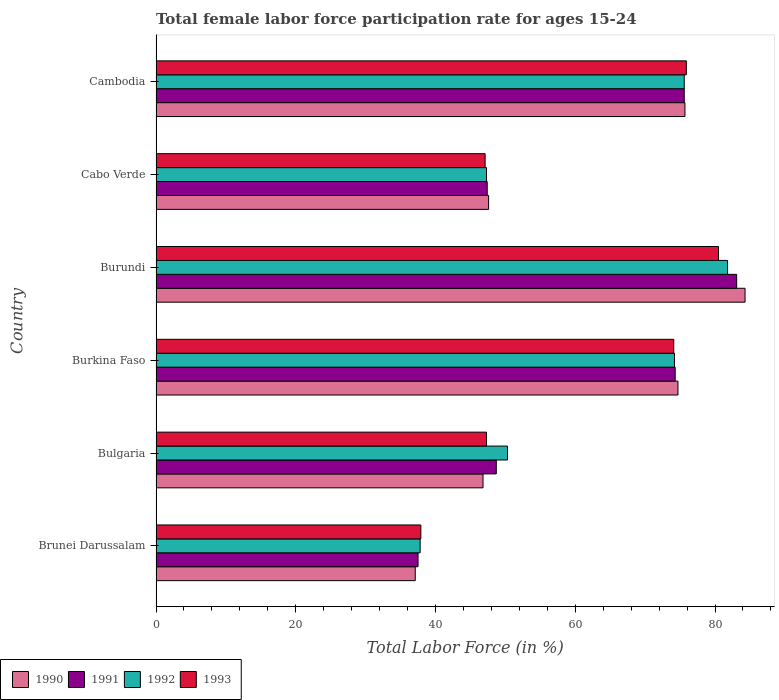How many groups of bars are there?
Ensure brevity in your answer.  6. Are the number of bars per tick equal to the number of legend labels?
Offer a terse response. Yes. How many bars are there on the 4th tick from the top?
Offer a very short reply. 4. What is the label of the 1st group of bars from the top?
Provide a succinct answer. Cambodia. In how many cases, is the number of bars for a given country not equal to the number of legend labels?
Your answer should be compact. 0. What is the female labor force participation rate in 1990 in Cambodia?
Offer a terse response. 75.7. Across all countries, what is the maximum female labor force participation rate in 1992?
Your response must be concise. 81.8. Across all countries, what is the minimum female labor force participation rate in 1992?
Offer a terse response. 37.8. In which country was the female labor force participation rate in 1993 maximum?
Your answer should be very brief. Burundi. In which country was the female labor force participation rate in 1993 minimum?
Make the answer very short. Brunei Darussalam. What is the total female labor force participation rate in 1990 in the graph?
Offer a very short reply. 366.2. What is the difference between the female labor force participation rate in 1991 in Bulgaria and that in Cabo Verde?
Offer a very short reply. 1.3. What is the difference between the female labor force participation rate in 1993 in Brunei Darussalam and the female labor force participation rate in 1991 in Bulgaria?
Make the answer very short. -10.8. What is the average female labor force participation rate in 1993 per country?
Give a very brief answer. 60.47. What is the difference between the female labor force participation rate in 1993 and female labor force participation rate in 1992 in Cambodia?
Offer a terse response. 0.3. What is the ratio of the female labor force participation rate in 1992 in Brunei Darussalam to that in Cabo Verde?
Provide a short and direct response. 0.8. Is the female labor force participation rate in 1990 in Burundi less than that in Cambodia?
Your answer should be compact. No. Is the difference between the female labor force participation rate in 1993 in Bulgaria and Cabo Verde greater than the difference between the female labor force participation rate in 1992 in Bulgaria and Cabo Verde?
Give a very brief answer. No. What is the difference between the highest and the second highest female labor force participation rate in 1993?
Provide a short and direct response. 4.6. What is the difference between the highest and the lowest female labor force participation rate in 1991?
Keep it short and to the point. 45.6. In how many countries, is the female labor force participation rate in 1992 greater than the average female labor force participation rate in 1992 taken over all countries?
Offer a very short reply. 3. Is the sum of the female labor force participation rate in 1992 in Bulgaria and Burkina Faso greater than the maximum female labor force participation rate in 1990 across all countries?
Your response must be concise. Yes. Is it the case that in every country, the sum of the female labor force participation rate in 1993 and female labor force participation rate in 1990 is greater than the sum of female labor force participation rate in 1991 and female labor force participation rate in 1992?
Provide a short and direct response. No. What does the 1st bar from the top in Cambodia represents?
Ensure brevity in your answer.  1993. How many bars are there?
Keep it short and to the point. 24. What is the difference between two consecutive major ticks on the X-axis?
Make the answer very short. 20. Are the values on the major ticks of X-axis written in scientific E-notation?
Give a very brief answer. No. Does the graph contain any zero values?
Your answer should be compact. No. How are the legend labels stacked?
Offer a terse response. Horizontal. What is the title of the graph?
Your response must be concise. Total female labor force participation rate for ages 15-24. Does "1992" appear as one of the legend labels in the graph?
Ensure brevity in your answer.  Yes. What is the label or title of the X-axis?
Provide a short and direct response. Total Labor Force (in %). What is the label or title of the Y-axis?
Provide a short and direct response. Country. What is the Total Labor Force (in %) of 1990 in Brunei Darussalam?
Offer a very short reply. 37.1. What is the Total Labor Force (in %) in 1991 in Brunei Darussalam?
Provide a short and direct response. 37.5. What is the Total Labor Force (in %) in 1992 in Brunei Darussalam?
Your response must be concise. 37.8. What is the Total Labor Force (in %) in 1993 in Brunei Darussalam?
Ensure brevity in your answer.  37.9. What is the Total Labor Force (in %) in 1990 in Bulgaria?
Provide a short and direct response. 46.8. What is the Total Labor Force (in %) in 1991 in Bulgaria?
Provide a succinct answer. 48.7. What is the Total Labor Force (in %) in 1992 in Bulgaria?
Provide a succinct answer. 50.3. What is the Total Labor Force (in %) of 1993 in Bulgaria?
Give a very brief answer. 47.3. What is the Total Labor Force (in %) in 1990 in Burkina Faso?
Offer a terse response. 74.7. What is the Total Labor Force (in %) in 1991 in Burkina Faso?
Keep it short and to the point. 74.3. What is the Total Labor Force (in %) of 1992 in Burkina Faso?
Offer a very short reply. 74.2. What is the Total Labor Force (in %) of 1993 in Burkina Faso?
Give a very brief answer. 74.1. What is the Total Labor Force (in %) in 1990 in Burundi?
Your answer should be compact. 84.3. What is the Total Labor Force (in %) in 1991 in Burundi?
Make the answer very short. 83.1. What is the Total Labor Force (in %) of 1992 in Burundi?
Offer a terse response. 81.8. What is the Total Labor Force (in %) of 1993 in Burundi?
Keep it short and to the point. 80.5. What is the Total Labor Force (in %) in 1990 in Cabo Verde?
Ensure brevity in your answer.  47.6. What is the Total Labor Force (in %) in 1991 in Cabo Verde?
Offer a very short reply. 47.4. What is the Total Labor Force (in %) in 1992 in Cabo Verde?
Offer a terse response. 47.3. What is the Total Labor Force (in %) of 1993 in Cabo Verde?
Make the answer very short. 47.1. What is the Total Labor Force (in %) in 1990 in Cambodia?
Your answer should be very brief. 75.7. What is the Total Labor Force (in %) in 1991 in Cambodia?
Make the answer very short. 75.6. What is the Total Labor Force (in %) of 1992 in Cambodia?
Give a very brief answer. 75.6. What is the Total Labor Force (in %) of 1993 in Cambodia?
Make the answer very short. 75.9. Across all countries, what is the maximum Total Labor Force (in %) in 1990?
Provide a succinct answer. 84.3. Across all countries, what is the maximum Total Labor Force (in %) of 1991?
Give a very brief answer. 83.1. Across all countries, what is the maximum Total Labor Force (in %) in 1992?
Keep it short and to the point. 81.8. Across all countries, what is the maximum Total Labor Force (in %) of 1993?
Your answer should be compact. 80.5. Across all countries, what is the minimum Total Labor Force (in %) of 1990?
Your answer should be very brief. 37.1. Across all countries, what is the minimum Total Labor Force (in %) in 1991?
Offer a very short reply. 37.5. Across all countries, what is the minimum Total Labor Force (in %) of 1992?
Your answer should be compact. 37.8. Across all countries, what is the minimum Total Labor Force (in %) of 1993?
Provide a succinct answer. 37.9. What is the total Total Labor Force (in %) in 1990 in the graph?
Ensure brevity in your answer.  366.2. What is the total Total Labor Force (in %) in 1991 in the graph?
Make the answer very short. 366.6. What is the total Total Labor Force (in %) in 1992 in the graph?
Ensure brevity in your answer.  367. What is the total Total Labor Force (in %) of 1993 in the graph?
Offer a terse response. 362.8. What is the difference between the Total Labor Force (in %) in 1990 in Brunei Darussalam and that in Bulgaria?
Your response must be concise. -9.7. What is the difference between the Total Labor Force (in %) of 1990 in Brunei Darussalam and that in Burkina Faso?
Provide a succinct answer. -37.6. What is the difference between the Total Labor Force (in %) of 1991 in Brunei Darussalam and that in Burkina Faso?
Keep it short and to the point. -36.8. What is the difference between the Total Labor Force (in %) of 1992 in Brunei Darussalam and that in Burkina Faso?
Keep it short and to the point. -36.4. What is the difference between the Total Labor Force (in %) in 1993 in Brunei Darussalam and that in Burkina Faso?
Offer a terse response. -36.2. What is the difference between the Total Labor Force (in %) of 1990 in Brunei Darussalam and that in Burundi?
Your response must be concise. -47.2. What is the difference between the Total Labor Force (in %) of 1991 in Brunei Darussalam and that in Burundi?
Your response must be concise. -45.6. What is the difference between the Total Labor Force (in %) in 1992 in Brunei Darussalam and that in Burundi?
Your answer should be compact. -44. What is the difference between the Total Labor Force (in %) in 1993 in Brunei Darussalam and that in Burundi?
Provide a short and direct response. -42.6. What is the difference between the Total Labor Force (in %) of 1991 in Brunei Darussalam and that in Cabo Verde?
Offer a terse response. -9.9. What is the difference between the Total Labor Force (in %) in 1992 in Brunei Darussalam and that in Cabo Verde?
Ensure brevity in your answer.  -9.5. What is the difference between the Total Labor Force (in %) in 1993 in Brunei Darussalam and that in Cabo Verde?
Give a very brief answer. -9.2. What is the difference between the Total Labor Force (in %) in 1990 in Brunei Darussalam and that in Cambodia?
Offer a very short reply. -38.6. What is the difference between the Total Labor Force (in %) of 1991 in Brunei Darussalam and that in Cambodia?
Offer a very short reply. -38.1. What is the difference between the Total Labor Force (in %) of 1992 in Brunei Darussalam and that in Cambodia?
Your answer should be very brief. -37.8. What is the difference between the Total Labor Force (in %) in 1993 in Brunei Darussalam and that in Cambodia?
Ensure brevity in your answer.  -38. What is the difference between the Total Labor Force (in %) of 1990 in Bulgaria and that in Burkina Faso?
Provide a succinct answer. -27.9. What is the difference between the Total Labor Force (in %) of 1991 in Bulgaria and that in Burkina Faso?
Keep it short and to the point. -25.6. What is the difference between the Total Labor Force (in %) of 1992 in Bulgaria and that in Burkina Faso?
Give a very brief answer. -23.9. What is the difference between the Total Labor Force (in %) of 1993 in Bulgaria and that in Burkina Faso?
Keep it short and to the point. -26.8. What is the difference between the Total Labor Force (in %) in 1990 in Bulgaria and that in Burundi?
Your answer should be compact. -37.5. What is the difference between the Total Labor Force (in %) in 1991 in Bulgaria and that in Burundi?
Provide a succinct answer. -34.4. What is the difference between the Total Labor Force (in %) of 1992 in Bulgaria and that in Burundi?
Offer a very short reply. -31.5. What is the difference between the Total Labor Force (in %) of 1993 in Bulgaria and that in Burundi?
Give a very brief answer. -33.2. What is the difference between the Total Labor Force (in %) of 1991 in Bulgaria and that in Cabo Verde?
Your response must be concise. 1.3. What is the difference between the Total Labor Force (in %) in 1993 in Bulgaria and that in Cabo Verde?
Offer a terse response. 0.2. What is the difference between the Total Labor Force (in %) of 1990 in Bulgaria and that in Cambodia?
Provide a short and direct response. -28.9. What is the difference between the Total Labor Force (in %) in 1991 in Bulgaria and that in Cambodia?
Offer a very short reply. -26.9. What is the difference between the Total Labor Force (in %) in 1992 in Bulgaria and that in Cambodia?
Offer a terse response. -25.3. What is the difference between the Total Labor Force (in %) in 1993 in Bulgaria and that in Cambodia?
Keep it short and to the point. -28.6. What is the difference between the Total Labor Force (in %) of 1990 in Burkina Faso and that in Burundi?
Make the answer very short. -9.6. What is the difference between the Total Labor Force (in %) of 1991 in Burkina Faso and that in Burundi?
Your response must be concise. -8.8. What is the difference between the Total Labor Force (in %) of 1990 in Burkina Faso and that in Cabo Verde?
Your response must be concise. 27.1. What is the difference between the Total Labor Force (in %) in 1991 in Burkina Faso and that in Cabo Verde?
Ensure brevity in your answer.  26.9. What is the difference between the Total Labor Force (in %) in 1992 in Burkina Faso and that in Cabo Verde?
Ensure brevity in your answer.  26.9. What is the difference between the Total Labor Force (in %) in 1990 in Burkina Faso and that in Cambodia?
Offer a very short reply. -1. What is the difference between the Total Labor Force (in %) of 1991 in Burkina Faso and that in Cambodia?
Your answer should be compact. -1.3. What is the difference between the Total Labor Force (in %) in 1992 in Burkina Faso and that in Cambodia?
Offer a terse response. -1.4. What is the difference between the Total Labor Force (in %) in 1990 in Burundi and that in Cabo Verde?
Your answer should be very brief. 36.7. What is the difference between the Total Labor Force (in %) of 1991 in Burundi and that in Cabo Verde?
Provide a short and direct response. 35.7. What is the difference between the Total Labor Force (in %) of 1992 in Burundi and that in Cabo Verde?
Your answer should be compact. 34.5. What is the difference between the Total Labor Force (in %) in 1993 in Burundi and that in Cabo Verde?
Your answer should be very brief. 33.4. What is the difference between the Total Labor Force (in %) in 1990 in Burundi and that in Cambodia?
Provide a succinct answer. 8.6. What is the difference between the Total Labor Force (in %) in 1990 in Cabo Verde and that in Cambodia?
Your answer should be very brief. -28.1. What is the difference between the Total Labor Force (in %) in 1991 in Cabo Verde and that in Cambodia?
Make the answer very short. -28.2. What is the difference between the Total Labor Force (in %) in 1992 in Cabo Verde and that in Cambodia?
Keep it short and to the point. -28.3. What is the difference between the Total Labor Force (in %) of 1993 in Cabo Verde and that in Cambodia?
Your response must be concise. -28.8. What is the difference between the Total Labor Force (in %) in 1990 in Brunei Darussalam and the Total Labor Force (in %) in 1992 in Bulgaria?
Ensure brevity in your answer.  -13.2. What is the difference between the Total Labor Force (in %) in 1991 in Brunei Darussalam and the Total Labor Force (in %) in 1992 in Bulgaria?
Give a very brief answer. -12.8. What is the difference between the Total Labor Force (in %) in 1991 in Brunei Darussalam and the Total Labor Force (in %) in 1993 in Bulgaria?
Your answer should be very brief. -9.8. What is the difference between the Total Labor Force (in %) of 1990 in Brunei Darussalam and the Total Labor Force (in %) of 1991 in Burkina Faso?
Provide a succinct answer. -37.2. What is the difference between the Total Labor Force (in %) of 1990 in Brunei Darussalam and the Total Labor Force (in %) of 1992 in Burkina Faso?
Your response must be concise. -37.1. What is the difference between the Total Labor Force (in %) of 1990 in Brunei Darussalam and the Total Labor Force (in %) of 1993 in Burkina Faso?
Your answer should be compact. -37. What is the difference between the Total Labor Force (in %) in 1991 in Brunei Darussalam and the Total Labor Force (in %) in 1992 in Burkina Faso?
Offer a very short reply. -36.7. What is the difference between the Total Labor Force (in %) of 1991 in Brunei Darussalam and the Total Labor Force (in %) of 1993 in Burkina Faso?
Keep it short and to the point. -36.6. What is the difference between the Total Labor Force (in %) in 1992 in Brunei Darussalam and the Total Labor Force (in %) in 1993 in Burkina Faso?
Your response must be concise. -36.3. What is the difference between the Total Labor Force (in %) in 1990 in Brunei Darussalam and the Total Labor Force (in %) in 1991 in Burundi?
Offer a terse response. -46. What is the difference between the Total Labor Force (in %) in 1990 in Brunei Darussalam and the Total Labor Force (in %) in 1992 in Burundi?
Keep it short and to the point. -44.7. What is the difference between the Total Labor Force (in %) in 1990 in Brunei Darussalam and the Total Labor Force (in %) in 1993 in Burundi?
Make the answer very short. -43.4. What is the difference between the Total Labor Force (in %) of 1991 in Brunei Darussalam and the Total Labor Force (in %) of 1992 in Burundi?
Offer a very short reply. -44.3. What is the difference between the Total Labor Force (in %) in 1991 in Brunei Darussalam and the Total Labor Force (in %) in 1993 in Burundi?
Your response must be concise. -43. What is the difference between the Total Labor Force (in %) in 1992 in Brunei Darussalam and the Total Labor Force (in %) in 1993 in Burundi?
Your answer should be compact. -42.7. What is the difference between the Total Labor Force (in %) in 1990 in Brunei Darussalam and the Total Labor Force (in %) in 1992 in Cabo Verde?
Your answer should be very brief. -10.2. What is the difference between the Total Labor Force (in %) in 1991 in Brunei Darussalam and the Total Labor Force (in %) in 1993 in Cabo Verde?
Your answer should be very brief. -9.6. What is the difference between the Total Labor Force (in %) in 1990 in Brunei Darussalam and the Total Labor Force (in %) in 1991 in Cambodia?
Your response must be concise. -38.5. What is the difference between the Total Labor Force (in %) of 1990 in Brunei Darussalam and the Total Labor Force (in %) of 1992 in Cambodia?
Make the answer very short. -38.5. What is the difference between the Total Labor Force (in %) in 1990 in Brunei Darussalam and the Total Labor Force (in %) in 1993 in Cambodia?
Offer a terse response. -38.8. What is the difference between the Total Labor Force (in %) of 1991 in Brunei Darussalam and the Total Labor Force (in %) of 1992 in Cambodia?
Offer a terse response. -38.1. What is the difference between the Total Labor Force (in %) in 1991 in Brunei Darussalam and the Total Labor Force (in %) in 1993 in Cambodia?
Make the answer very short. -38.4. What is the difference between the Total Labor Force (in %) in 1992 in Brunei Darussalam and the Total Labor Force (in %) in 1993 in Cambodia?
Provide a short and direct response. -38.1. What is the difference between the Total Labor Force (in %) in 1990 in Bulgaria and the Total Labor Force (in %) in 1991 in Burkina Faso?
Your answer should be very brief. -27.5. What is the difference between the Total Labor Force (in %) of 1990 in Bulgaria and the Total Labor Force (in %) of 1992 in Burkina Faso?
Provide a short and direct response. -27.4. What is the difference between the Total Labor Force (in %) in 1990 in Bulgaria and the Total Labor Force (in %) in 1993 in Burkina Faso?
Your answer should be compact. -27.3. What is the difference between the Total Labor Force (in %) of 1991 in Bulgaria and the Total Labor Force (in %) of 1992 in Burkina Faso?
Keep it short and to the point. -25.5. What is the difference between the Total Labor Force (in %) of 1991 in Bulgaria and the Total Labor Force (in %) of 1993 in Burkina Faso?
Your answer should be very brief. -25.4. What is the difference between the Total Labor Force (in %) in 1992 in Bulgaria and the Total Labor Force (in %) in 1993 in Burkina Faso?
Your response must be concise. -23.8. What is the difference between the Total Labor Force (in %) of 1990 in Bulgaria and the Total Labor Force (in %) of 1991 in Burundi?
Your response must be concise. -36.3. What is the difference between the Total Labor Force (in %) in 1990 in Bulgaria and the Total Labor Force (in %) in 1992 in Burundi?
Your answer should be very brief. -35. What is the difference between the Total Labor Force (in %) of 1990 in Bulgaria and the Total Labor Force (in %) of 1993 in Burundi?
Ensure brevity in your answer.  -33.7. What is the difference between the Total Labor Force (in %) in 1991 in Bulgaria and the Total Labor Force (in %) in 1992 in Burundi?
Ensure brevity in your answer.  -33.1. What is the difference between the Total Labor Force (in %) of 1991 in Bulgaria and the Total Labor Force (in %) of 1993 in Burundi?
Offer a terse response. -31.8. What is the difference between the Total Labor Force (in %) of 1992 in Bulgaria and the Total Labor Force (in %) of 1993 in Burundi?
Make the answer very short. -30.2. What is the difference between the Total Labor Force (in %) in 1991 in Bulgaria and the Total Labor Force (in %) in 1992 in Cabo Verde?
Your response must be concise. 1.4. What is the difference between the Total Labor Force (in %) of 1992 in Bulgaria and the Total Labor Force (in %) of 1993 in Cabo Verde?
Your answer should be very brief. 3.2. What is the difference between the Total Labor Force (in %) of 1990 in Bulgaria and the Total Labor Force (in %) of 1991 in Cambodia?
Keep it short and to the point. -28.8. What is the difference between the Total Labor Force (in %) of 1990 in Bulgaria and the Total Labor Force (in %) of 1992 in Cambodia?
Ensure brevity in your answer.  -28.8. What is the difference between the Total Labor Force (in %) in 1990 in Bulgaria and the Total Labor Force (in %) in 1993 in Cambodia?
Ensure brevity in your answer.  -29.1. What is the difference between the Total Labor Force (in %) in 1991 in Bulgaria and the Total Labor Force (in %) in 1992 in Cambodia?
Your answer should be compact. -26.9. What is the difference between the Total Labor Force (in %) in 1991 in Bulgaria and the Total Labor Force (in %) in 1993 in Cambodia?
Provide a succinct answer. -27.2. What is the difference between the Total Labor Force (in %) in 1992 in Bulgaria and the Total Labor Force (in %) in 1993 in Cambodia?
Your answer should be very brief. -25.6. What is the difference between the Total Labor Force (in %) of 1990 in Burkina Faso and the Total Labor Force (in %) of 1991 in Burundi?
Offer a very short reply. -8.4. What is the difference between the Total Labor Force (in %) in 1990 in Burkina Faso and the Total Labor Force (in %) in 1993 in Burundi?
Provide a short and direct response. -5.8. What is the difference between the Total Labor Force (in %) in 1991 in Burkina Faso and the Total Labor Force (in %) in 1992 in Burundi?
Offer a very short reply. -7.5. What is the difference between the Total Labor Force (in %) in 1991 in Burkina Faso and the Total Labor Force (in %) in 1993 in Burundi?
Provide a succinct answer. -6.2. What is the difference between the Total Labor Force (in %) in 1990 in Burkina Faso and the Total Labor Force (in %) in 1991 in Cabo Verde?
Give a very brief answer. 27.3. What is the difference between the Total Labor Force (in %) of 1990 in Burkina Faso and the Total Labor Force (in %) of 1992 in Cabo Verde?
Provide a short and direct response. 27.4. What is the difference between the Total Labor Force (in %) of 1990 in Burkina Faso and the Total Labor Force (in %) of 1993 in Cabo Verde?
Ensure brevity in your answer.  27.6. What is the difference between the Total Labor Force (in %) in 1991 in Burkina Faso and the Total Labor Force (in %) in 1993 in Cabo Verde?
Ensure brevity in your answer.  27.2. What is the difference between the Total Labor Force (in %) in 1992 in Burkina Faso and the Total Labor Force (in %) in 1993 in Cabo Verde?
Make the answer very short. 27.1. What is the difference between the Total Labor Force (in %) of 1990 in Burkina Faso and the Total Labor Force (in %) of 1991 in Cambodia?
Ensure brevity in your answer.  -0.9. What is the difference between the Total Labor Force (in %) in 1990 in Burkina Faso and the Total Labor Force (in %) in 1992 in Cambodia?
Ensure brevity in your answer.  -0.9. What is the difference between the Total Labor Force (in %) in 1990 in Burkina Faso and the Total Labor Force (in %) in 1993 in Cambodia?
Make the answer very short. -1.2. What is the difference between the Total Labor Force (in %) in 1991 in Burkina Faso and the Total Labor Force (in %) in 1992 in Cambodia?
Your answer should be compact. -1.3. What is the difference between the Total Labor Force (in %) of 1992 in Burkina Faso and the Total Labor Force (in %) of 1993 in Cambodia?
Your response must be concise. -1.7. What is the difference between the Total Labor Force (in %) in 1990 in Burundi and the Total Labor Force (in %) in 1991 in Cabo Verde?
Provide a short and direct response. 36.9. What is the difference between the Total Labor Force (in %) in 1990 in Burundi and the Total Labor Force (in %) in 1992 in Cabo Verde?
Your answer should be very brief. 37. What is the difference between the Total Labor Force (in %) of 1990 in Burundi and the Total Labor Force (in %) of 1993 in Cabo Verde?
Offer a very short reply. 37.2. What is the difference between the Total Labor Force (in %) in 1991 in Burundi and the Total Labor Force (in %) in 1992 in Cabo Verde?
Provide a succinct answer. 35.8. What is the difference between the Total Labor Force (in %) of 1991 in Burundi and the Total Labor Force (in %) of 1993 in Cabo Verde?
Provide a short and direct response. 36. What is the difference between the Total Labor Force (in %) of 1992 in Burundi and the Total Labor Force (in %) of 1993 in Cabo Verde?
Your answer should be compact. 34.7. What is the difference between the Total Labor Force (in %) in 1990 in Burundi and the Total Labor Force (in %) in 1993 in Cambodia?
Provide a succinct answer. 8.4. What is the difference between the Total Labor Force (in %) of 1991 in Burundi and the Total Labor Force (in %) of 1993 in Cambodia?
Offer a very short reply. 7.2. What is the difference between the Total Labor Force (in %) in 1990 in Cabo Verde and the Total Labor Force (in %) in 1991 in Cambodia?
Make the answer very short. -28. What is the difference between the Total Labor Force (in %) in 1990 in Cabo Verde and the Total Labor Force (in %) in 1993 in Cambodia?
Offer a very short reply. -28.3. What is the difference between the Total Labor Force (in %) in 1991 in Cabo Verde and the Total Labor Force (in %) in 1992 in Cambodia?
Keep it short and to the point. -28.2. What is the difference between the Total Labor Force (in %) in 1991 in Cabo Verde and the Total Labor Force (in %) in 1993 in Cambodia?
Your answer should be very brief. -28.5. What is the difference between the Total Labor Force (in %) in 1992 in Cabo Verde and the Total Labor Force (in %) in 1993 in Cambodia?
Offer a very short reply. -28.6. What is the average Total Labor Force (in %) in 1990 per country?
Make the answer very short. 61.03. What is the average Total Labor Force (in %) of 1991 per country?
Your answer should be compact. 61.1. What is the average Total Labor Force (in %) in 1992 per country?
Your response must be concise. 61.17. What is the average Total Labor Force (in %) in 1993 per country?
Keep it short and to the point. 60.47. What is the difference between the Total Labor Force (in %) in 1990 and Total Labor Force (in %) in 1993 in Brunei Darussalam?
Give a very brief answer. -0.8. What is the difference between the Total Labor Force (in %) in 1990 and Total Labor Force (in %) in 1991 in Bulgaria?
Your answer should be compact. -1.9. What is the difference between the Total Labor Force (in %) of 1991 and Total Labor Force (in %) of 1993 in Bulgaria?
Offer a terse response. 1.4. What is the difference between the Total Labor Force (in %) of 1990 and Total Labor Force (in %) of 1991 in Burkina Faso?
Provide a succinct answer. 0.4. What is the difference between the Total Labor Force (in %) of 1990 and Total Labor Force (in %) of 1993 in Burkina Faso?
Your response must be concise. 0.6. What is the difference between the Total Labor Force (in %) in 1991 and Total Labor Force (in %) in 1992 in Burkina Faso?
Offer a terse response. 0.1. What is the difference between the Total Labor Force (in %) in 1991 and Total Labor Force (in %) in 1993 in Burkina Faso?
Your answer should be very brief. 0.2. What is the difference between the Total Labor Force (in %) in 1990 and Total Labor Force (in %) in 1992 in Burundi?
Your answer should be compact. 2.5. What is the difference between the Total Labor Force (in %) of 1990 and Total Labor Force (in %) of 1993 in Burundi?
Provide a succinct answer. 3.8. What is the difference between the Total Labor Force (in %) of 1991 and Total Labor Force (in %) of 1993 in Burundi?
Your answer should be compact. 2.6. What is the difference between the Total Labor Force (in %) in 1990 and Total Labor Force (in %) in 1992 in Cabo Verde?
Give a very brief answer. 0.3. What is the difference between the Total Labor Force (in %) of 1990 and Total Labor Force (in %) of 1993 in Cabo Verde?
Keep it short and to the point. 0.5. What is the difference between the Total Labor Force (in %) in 1991 and Total Labor Force (in %) in 1992 in Cabo Verde?
Ensure brevity in your answer.  0.1. What is the difference between the Total Labor Force (in %) of 1992 and Total Labor Force (in %) of 1993 in Cabo Verde?
Your answer should be very brief. 0.2. What is the difference between the Total Labor Force (in %) of 1990 and Total Labor Force (in %) of 1993 in Cambodia?
Offer a very short reply. -0.2. What is the difference between the Total Labor Force (in %) of 1991 and Total Labor Force (in %) of 1992 in Cambodia?
Ensure brevity in your answer.  0. What is the difference between the Total Labor Force (in %) in 1991 and Total Labor Force (in %) in 1993 in Cambodia?
Keep it short and to the point. -0.3. What is the ratio of the Total Labor Force (in %) of 1990 in Brunei Darussalam to that in Bulgaria?
Provide a succinct answer. 0.79. What is the ratio of the Total Labor Force (in %) in 1991 in Brunei Darussalam to that in Bulgaria?
Ensure brevity in your answer.  0.77. What is the ratio of the Total Labor Force (in %) in 1992 in Brunei Darussalam to that in Bulgaria?
Provide a short and direct response. 0.75. What is the ratio of the Total Labor Force (in %) in 1993 in Brunei Darussalam to that in Bulgaria?
Your answer should be very brief. 0.8. What is the ratio of the Total Labor Force (in %) of 1990 in Brunei Darussalam to that in Burkina Faso?
Provide a short and direct response. 0.5. What is the ratio of the Total Labor Force (in %) of 1991 in Brunei Darussalam to that in Burkina Faso?
Your response must be concise. 0.5. What is the ratio of the Total Labor Force (in %) in 1992 in Brunei Darussalam to that in Burkina Faso?
Provide a succinct answer. 0.51. What is the ratio of the Total Labor Force (in %) of 1993 in Brunei Darussalam to that in Burkina Faso?
Provide a short and direct response. 0.51. What is the ratio of the Total Labor Force (in %) in 1990 in Brunei Darussalam to that in Burundi?
Provide a succinct answer. 0.44. What is the ratio of the Total Labor Force (in %) of 1991 in Brunei Darussalam to that in Burundi?
Offer a terse response. 0.45. What is the ratio of the Total Labor Force (in %) in 1992 in Brunei Darussalam to that in Burundi?
Your answer should be very brief. 0.46. What is the ratio of the Total Labor Force (in %) of 1993 in Brunei Darussalam to that in Burundi?
Offer a terse response. 0.47. What is the ratio of the Total Labor Force (in %) in 1990 in Brunei Darussalam to that in Cabo Verde?
Offer a terse response. 0.78. What is the ratio of the Total Labor Force (in %) in 1991 in Brunei Darussalam to that in Cabo Verde?
Make the answer very short. 0.79. What is the ratio of the Total Labor Force (in %) of 1992 in Brunei Darussalam to that in Cabo Verde?
Provide a succinct answer. 0.8. What is the ratio of the Total Labor Force (in %) in 1993 in Brunei Darussalam to that in Cabo Verde?
Make the answer very short. 0.8. What is the ratio of the Total Labor Force (in %) of 1990 in Brunei Darussalam to that in Cambodia?
Give a very brief answer. 0.49. What is the ratio of the Total Labor Force (in %) of 1991 in Brunei Darussalam to that in Cambodia?
Your answer should be very brief. 0.5. What is the ratio of the Total Labor Force (in %) in 1992 in Brunei Darussalam to that in Cambodia?
Make the answer very short. 0.5. What is the ratio of the Total Labor Force (in %) in 1993 in Brunei Darussalam to that in Cambodia?
Give a very brief answer. 0.5. What is the ratio of the Total Labor Force (in %) of 1990 in Bulgaria to that in Burkina Faso?
Your answer should be compact. 0.63. What is the ratio of the Total Labor Force (in %) in 1991 in Bulgaria to that in Burkina Faso?
Provide a short and direct response. 0.66. What is the ratio of the Total Labor Force (in %) of 1992 in Bulgaria to that in Burkina Faso?
Offer a very short reply. 0.68. What is the ratio of the Total Labor Force (in %) in 1993 in Bulgaria to that in Burkina Faso?
Your response must be concise. 0.64. What is the ratio of the Total Labor Force (in %) in 1990 in Bulgaria to that in Burundi?
Keep it short and to the point. 0.56. What is the ratio of the Total Labor Force (in %) of 1991 in Bulgaria to that in Burundi?
Provide a succinct answer. 0.59. What is the ratio of the Total Labor Force (in %) in 1992 in Bulgaria to that in Burundi?
Ensure brevity in your answer.  0.61. What is the ratio of the Total Labor Force (in %) in 1993 in Bulgaria to that in Burundi?
Offer a terse response. 0.59. What is the ratio of the Total Labor Force (in %) in 1990 in Bulgaria to that in Cabo Verde?
Offer a terse response. 0.98. What is the ratio of the Total Labor Force (in %) in 1991 in Bulgaria to that in Cabo Verde?
Ensure brevity in your answer.  1.03. What is the ratio of the Total Labor Force (in %) in 1992 in Bulgaria to that in Cabo Verde?
Provide a succinct answer. 1.06. What is the ratio of the Total Labor Force (in %) of 1990 in Bulgaria to that in Cambodia?
Make the answer very short. 0.62. What is the ratio of the Total Labor Force (in %) in 1991 in Bulgaria to that in Cambodia?
Keep it short and to the point. 0.64. What is the ratio of the Total Labor Force (in %) of 1992 in Bulgaria to that in Cambodia?
Provide a short and direct response. 0.67. What is the ratio of the Total Labor Force (in %) of 1993 in Bulgaria to that in Cambodia?
Offer a terse response. 0.62. What is the ratio of the Total Labor Force (in %) in 1990 in Burkina Faso to that in Burundi?
Ensure brevity in your answer.  0.89. What is the ratio of the Total Labor Force (in %) in 1991 in Burkina Faso to that in Burundi?
Offer a very short reply. 0.89. What is the ratio of the Total Labor Force (in %) of 1992 in Burkina Faso to that in Burundi?
Ensure brevity in your answer.  0.91. What is the ratio of the Total Labor Force (in %) of 1993 in Burkina Faso to that in Burundi?
Your answer should be compact. 0.92. What is the ratio of the Total Labor Force (in %) in 1990 in Burkina Faso to that in Cabo Verde?
Make the answer very short. 1.57. What is the ratio of the Total Labor Force (in %) of 1991 in Burkina Faso to that in Cabo Verde?
Keep it short and to the point. 1.57. What is the ratio of the Total Labor Force (in %) in 1992 in Burkina Faso to that in Cabo Verde?
Give a very brief answer. 1.57. What is the ratio of the Total Labor Force (in %) of 1993 in Burkina Faso to that in Cabo Verde?
Your answer should be very brief. 1.57. What is the ratio of the Total Labor Force (in %) in 1991 in Burkina Faso to that in Cambodia?
Provide a succinct answer. 0.98. What is the ratio of the Total Labor Force (in %) of 1992 in Burkina Faso to that in Cambodia?
Provide a succinct answer. 0.98. What is the ratio of the Total Labor Force (in %) in 1993 in Burkina Faso to that in Cambodia?
Your response must be concise. 0.98. What is the ratio of the Total Labor Force (in %) of 1990 in Burundi to that in Cabo Verde?
Ensure brevity in your answer.  1.77. What is the ratio of the Total Labor Force (in %) in 1991 in Burundi to that in Cabo Verde?
Give a very brief answer. 1.75. What is the ratio of the Total Labor Force (in %) in 1992 in Burundi to that in Cabo Verde?
Your answer should be compact. 1.73. What is the ratio of the Total Labor Force (in %) of 1993 in Burundi to that in Cabo Verde?
Your answer should be compact. 1.71. What is the ratio of the Total Labor Force (in %) in 1990 in Burundi to that in Cambodia?
Your answer should be compact. 1.11. What is the ratio of the Total Labor Force (in %) of 1991 in Burundi to that in Cambodia?
Your response must be concise. 1.1. What is the ratio of the Total Labor Force (in %) in 1992 in Burundi to that in Cambodia?
Give a very brief answer. 1.08. What is the ratio of the Total Labor Force (in %) in 1993 in Burundi to that in Cambodia?
Provide a succinct answer. 1.06. What is the ratio of the Total Labor Force (in %) of 1990 in Cabo Verde to that in Cambodia?
Give a very brief answer. 0.63. What is the ratio of the Total Labor Force (in %) of 1991 in Cabo Verde to that in Cambodia?
Offer a terse response. 0.63. What is the ratio of the Total Labor Force (in %) of 1992 in Cabo Verde to that in Cambodia?
Give a very brief answer. 0.63. What is the ratio of the Total Labor Force (in %) in 1993 in Cabo Verde to that in Cambodia?
Keep it short and to the point. 0.62. What is the difference between the highest and the lowest Total Labor Force (in %) in 1990?
Provide a succinct answer. 47.2. What is the difference between the highest and the lowest Total Labor Force (in %) of 1991?
Offer a terse response. 45.6. What is the difference between the highest and the lowest Total Labor Force (in %) of 1993?
Make the answer very short. 42.6. 